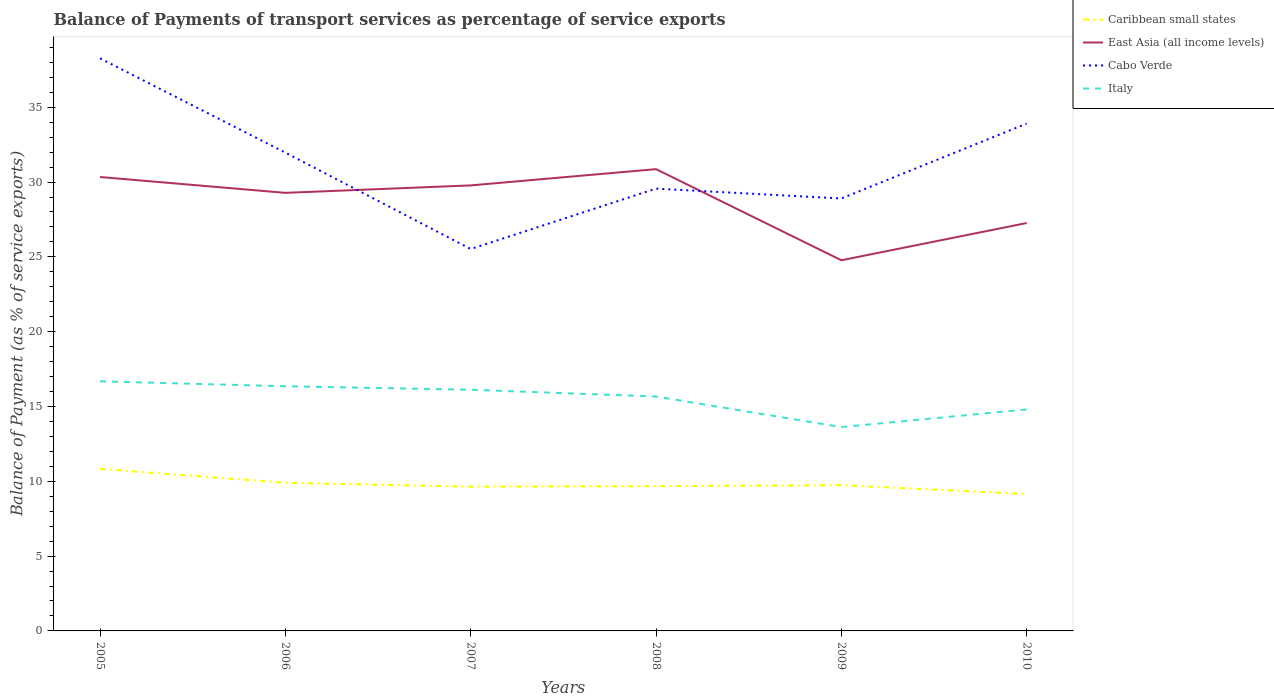Is the number of lines equal to the number of legend labels?
Keep it short and to the point. Yes. Across all years, what is the maximum balance of payments of transport services in Cabo Verde?
Give a very brief answer. 25.53. What is the total balance of payments of transport services in Cabo Verde in the graph?
Ensure brevity in your answer.  8.71. What is the difference between the highest and the second highest balance of payments of transport services in Italy?
Keep it short and to the point. 3.06. How many years are there in the graph?
Your answer should be very brief. 6. What is the difference between two consecutive major ticks on the Y-axis?
Keep it short and to the point. 5. Where does the legend appear in the graph?
Make the answer very short. Top right. How many legend labels are there?
Provide a succinct answer. 4. How are the legend labels stacked?
Provide a succinct answer. Vertical. What is the title of the graph?
Make the answer very short. Balance of Payments of transport services as percentage of service exports. Does "Myanmar" appear as one of the legend labels in the graph?
Provide a short and direct response. No. What is the label or title of the X-axis?
Provide a succinct answer. Years. What is the label or title of the Y-axis?
Offer a very short reply. Balance of Payment (as % of service exports). What is the Balance of Payment (as % of service exports) of Caribbean small states in 2005?
Ensure brevity in your answer.  10.83. What is the Balance of Payment (as % of service exports) of East Asia (all income levels) in 2005?
Your answer should be compact. 30.34. What is the Balance of Payment (as % of service exports) in Cabo Verde in 2005?
Offer a terse response. 38.27. What is the Balance of Payment (as % of service exports) in Italy in 2005?
Offer a very short reply. 16.68. What is the Balance of Payment (as % of service exports) in Caribbean small states in 2006?
Your response must be concise. 9.9. What is the Balance of Payment (as % of service exports) in East Asia (all income levels) in 2006?
Give a very brief answer. 29.28. What is the Balance of Payment (as % of service exports) of Cabo Verde in 2006?
Provide a short and direct response. 31.97. What is the Balance of Payment (as % of service exports) of Italy in 2006?
Give a very brief answer. 16.35. What is the Balance of Payment (as % of service exports) in Caribbean small states in 2007?
Your response must be concise. 9.64. What is the Balance of Payment (as % of service exports) of East Asia (all income levels) in 2007?
Your response must be concise. 29.78. What is the Balance of Payment (as % of service exports) in Cabo Verde in 2007?
Make the answer very short. 25.53. What is the Balance of Payment (as % of service exports) in Italy in 2007?
Your answer should be compact. 16.12. What is the Balance of Payment (as % of service exports) in Caribbean small states in 2008?
Provide a short and direct response. 9.67. What is the Balance of Payment (as % of service exports) of East Asia (all income levels) in 2008?
Your response must be concise. 30.86. What is the Balance of Payment (as % of service exports) in Cabo Verde in 2008?
Provide a short and direct response. 29.56. What is the Balance of Payment (as % of service exports) of Italy in 2008?
Offer a terse response. 15.67. What is the Balance of Payment (as % of service exports) of Caribbean small states in 2009?
Your answer should be very brief. 9.74. What is the Balance of Payment (as % of service exports) in East Asia (all income levels) in 2009?
Offer a very short reply. 24.77. What is the Balance of Payment (as % of service exports) in Cabo Verde in 2009?
Offer a very short reply. 28.9. What is the Balance of Payment (as % of service exports) of Italy in 2009?
Your answer should be very brief. 13.62. What is the Balance of Payment (as % of service exports) in Caribbean small states in 2010?
Your answer should be very brief. 9.15. What is the Balance of Payment (as % of service exports) in East Asia (all income levels) in 2010?
Provide a succinct answer. 27.26. What is the Balance of Payment (as % of service exports) in Cabo Verde in 2010?
Your answer should be very brief. 33.91. What is the Balance of Payment (as % of service exports) in Italy in 2010?
Your answer should be very brief. 14.8. Across all years, what is the maximum Balance of Payment (as % of service exports) in Caribbean small states?
Your response must be concise. 10.83. Across all years, what is the maximum Balance of Payment (as % of service exports) of East Asia (all income levels)?
Give a very brief answer. 30.86. Across all years, what is the maximum Balance of Payment (as % of service exports) of Cabo Verde?
Your answer should be very brief. 38.27. Across all years, what is the maximum Balance of Payment (as % of service exports) in Italy?
Your answer should be very brief. 16.68. Across all years, what is the minimum Balance of Payment (as % of service exports) of Caribbean small states?
Keep it short and to the point. 9.15. Across all years, what is the minimum Balance of Payment (as % of service exports) in East Asia (all income levels)?
Provide a short and direct response. 24.77. Across all years, what is the minimum Balance of Payment (as % of service exports) of Cabo Verde?
Give a very brief answer. 25.53. Across all years, what is the minimum Balance of Payment (as % of service exports) in Italy?
Your response must be concise. 13.62. What is the total Balance of Payment (as % of service exports) in Caribbean small states in the graph?
Give a very brief answer. 58.93. What is the total Balance of Payment (as % of service exports) in East Asia (all income levels) in the graph?
Ensure brevity in your answer.  172.29. What is the total Balance of Payment (as % of service exports) of Cabo Verde in the graph?
Your answer should be very brief. 188.13. What is the total Balance of Payment (as % of service exports) in Italy in the graph?
Offer a terse response. 93.25. What is the difference between the Balance of Payment (as % of service exports) of Caribbean small states in 2005 and that in 2006?
Provide a succinct answer. 0.93. What is the difference between the Balance of Payment (as % of service exports) of East Asia (all income levels) in 2005 and that in 2006?
Your answer should be compact. 1.06. What is the difference between the Balance of Payment (as % of service exports) of Cabo Verde in 2005 and that in 2006?
Ensure brevity in your answer.  6.3. What is the difference between the Balance of Payment (as % of service exports) of Italy in 2005 and that in 2006?
Offer a terse response. 0.33. What is the difference between the Balance of Payment (as % of service exports) in Caribbean small states in 2005 and that in 2007?
Give a very brief answer. 1.19. What is the difference between the Balance of Payment (as % of service exports) in East Asia (all income levels) in 2005 and that in 2007?
Your answer should be very brief. 0.56. What is the difference between the Balance of Payment (as % of service exports) of Cabo Verde in 2005 and that in 2007?
Offer a very short reply. 12.74. What is the difference between the Balance of Payment (as % of service exports) in Italy in 2005 and that in 2007?
Your answer should be very brief. 0.56. What is the difference between the Balance of Payment (as % of service exports) of Caribbean small states in 2005 and that in 2008?
Ensure brevity in your answer.  1.15. What is the difference between the Balance of Payment (as % of service exports) in East Asia (all income levels) in 2005 and that in 2008?
Your answer should be very brief. -0.53. What is the difference between the Balance of Payment (as % of service exports) in Cabo Verde in 2005 and that in 2008?
Offer a very short reply. 8.71. What is the difference between the Balance of Payment (as % of service exports) of Italy in 2005 and that in 2008?
Offer a terse response. 1.02. What is the difference between the Balance of Payment (as % of service exports) in Caribbean small states in 2005 and that in 2009?
Provide a succinct answer. 1.09. What is the difference between the Balance of Payment (as % of service exports) of East Asia (all income levels) in 2005 and that in 2009?
Give a very brief answer. 5.56. What is the difference between the Balance of Payment (as % of service exports) in Cabo Verde in 2005 and that in 2009?
Make the answer very short. 9.36. What is the difference between the Balance of Payment (as % of service exports) in Italy in 2005 and that in 2009?
Your answer should be very brief. 3.06. What is the difference between the Balance of Payment (as % of service exports) in Caribbean small states in 2005 and that in 2010?
Your answer should be compact. 1.68. What is the difference between the Balance of Payment (as % of service exports) in East Asia (all income levels) in 2005 and that in 2010?
Your answer should be compact. 3.08. What is the difference between the Balance of Payment (as % of service exports) of Cabo Verde in 2005 and that in 2010?
Make the answer very short. 4.36. What is the difference between the Balance of Payment (as % of service exports) of Italy in 2005 and that in 2010?
Make the answer very short. 1.88. What is the difference between the Balance of Payment (as % of service exports) in Caribbean small states in 2006 and that in 2007?
Your answer should be compact. 0.26. What is the difference between the Balance of Payment (as % of service exports) in East Asia (all income levels) in 2006 and that in 2007?
Offer a terse response. -0.5. What is the difference between the Balance of Payment (as % of service exports) in Cabo Verde in 2006 and that in 2007?
Offer a terse response. 6.44. What is the difference between the Balance of Payment (as % of service exports) in Italy in 2006 and that in 2007?
Keep it short and to the point. 0.23. What is the difference between the Balance of Payment (as % of service exports) in Caribbean small states in 2006 and that in 2008?
Provide a short and direct response. 0.23. What is the difference between the Balance of Payment (as % of service exports) in East Asia (all income levels) in 2006 and that in 2008?
Give a very brief answer. -1.58. What is the difference between the Balance of Payment (as % of service exports) of Cabo Verde in 2006 and that in 2008?
Provide a succinct answer. 2.41. What is the difference between the Balance of Payment (as % of service exports) in Italy in 2006 and that in 2008?
Offer a very short reply. 0.69. What is the difference between the Balance of Payment (as % of service exports) in Caribbean small states in 2006 and that in 2009?
Your response must be concise. 0.16. What is the difference between the Balance of Payment (as % of service exports) in East Asia (all income levels) in 2006 and that in 2009?
Provide a succinct answer. 4.51. What is the difference between the Balance of Payment (as % of service exports) of Cabo Verde in 2006 and that in 2009?
Your answer should be compact. 3.06. What is the difference between the Balance of Payment (as % of service exports) in Italy in 2006 and that in 2009?
Give a very brief answer. 2.73. What is the difference between the Balance of Payment (as % of service exports) in Caribbean small states in 2006 and that in 2010?
Your answer should be very brief. 0.75. What is the difference between the Balance of Payment (as % of service exports) of East Asia (all income levels) in 2006 and that in 2010?
Provide a succinct answer. 2.02. What is the difference between the Balance of Payment (as % of service exports) in Cabo Verde in 2006 and that in 2010?
Offer a very short reply. -1.94. What is the difference between the Balance of Payment (as % of service exports) in Italy in 2006 and that in 2010?
Give a very brief answer. 1.55. What is the difference between the Balance of Payment (as % of service exports) in Caribbean small states in 2007 and that in 2008?
Offer a terse response. -0.04. What is the difference between the Balance of Payment (as % of service exports) of East Asia (all income levels) in 2007 and that in 2008?
Your response must be concise. -1.09. What is the difference between the Balance of Payment (as % of service exports) in Cabo Verde in 2007 and that in 2008?
Provide a succinct answer. -4.03. What is the difference between the Balance of Payment (as % of service exports) in Italy in 2007 and that in 2008?
Your answer should be compact. 0.45. What is the difference between the Balance of Payment (as % of service exports) of Caribbean small states in 2007 and that in 2009?
Offer a very short reply. -0.1. What is the difference between the Balance of Payment (as % of service exports) of East Asia (all income levels) in 2007 and that in 2009?
Provide a succinct answer. 5. What is the difference between the Balance of Payment (as % of service exports) in Cabo Verde in 2007 and that in 2009?
Provide a short and direct response. -3.38. What is the difference between the Balance of Payment (as % of service exports) of Italy in 2007 and that in 2009?
Your answer should be compact. 2.49. What is the difference between the Balance of Payment (as % of service exports) in Caribbean small states in 2007 and that in 2010?
Keep it short and to the point. 0.49. What is the difference between the Balance of Payment (as % of service exports) in East Asia (all income levels) in 2007 and that in 2010?
Give a very brief answer. 2.51. What is the difference between the Balance of Payment (as % of service exports) of Cabo Verde in 2007 and that in 2010?
Provide a succinct answer. -8.38. What is the difference between the Balance of Payment (as % of service exports) of Italy in 2007 and that in 2010?
Your response must be concise. 1.32. What is the difference between the Balance of Payment (as % of service exports) in Caribbean small states in 2008 and that in 2009?
Offer a very short reply. -0.07. What is the difference between the Balance of Payment (as % of service exports) in East Asia (all income levels) in 2008 and that in 2009?
Your answer should be compact. 6.09. What is the difference between the Balance of Payment (as % of service exports) of Cabo Verde in 2008 and that in 2009?
Offer a very short reply. 0.66. What is the difference between the Balance of Payment (as % of service exports) of Italy in 2008 and that in 2009?
Provide a short and direct response. 2.04. What is the difference between the Balance of Payment (as % of service exports) of Caribbean small states in 2008 and that in 2010?
Offer a terse response. 0.52. What is the difference between the Balance of Payment (as % of service exports) of East Asia (all income levels) in 2008 and that in 2010?
Ensure brevity in your answer.  3.6. What is the difference between the Balance of Payment (as % of service exports) in Cabo Verde in 2008 and that in 2010?
Your answer should be compact. -4.35. What is the difference between the Balance of Payment (as % of service exports) of Italy in 2008 and that in 2010?
Your answer should be very brief. 0.86. What is the difference between the Balance of Payment (as % of service exports) of Caribbean small states in 2009 and that in 2010?
Offer a terse response. 0.59. What is the difference between the Balance of Payment (as % of service exports) of East Asia (all income levels) in 2009 and that in 2010?
Make the answer very short. -2.49. What is the difference between the Balance of Payment (as % of service exports) in Cabo Verde in 2009 and that in 2010?
Your answer should be compact. -5.01. What is the difference between the Balance of Payment (as % of service exports) in Italy in 2009 and that in 2010?
Provide a short and direct response. -1.18. What is the difference between the Balance of Payment (as % of service exports) in Caribbean small states in 2005 and the Balance of Payment (as % of service exports) in East Asia (all income levels) in 2006?
Offer a very short reply. -18.45. What is the difference between the Balance of Payment (as % of service exports) in Caribbean small states in 2005 and the Balance of Payment (as % of service exports) in Cabo Verde in 2006?
Your answer should be very brief. -21.14. What is the difference between the Balance of Payment (as % of service exports) in Caribbean small states in 2005 and the Balance of Payment (as % of service exports) in Italy in 2006?
Ensure brevity in your answer.  -5.52. What is the difference between the Balance of Payment (as % of service exports) of East Asia (all income levels) in 2005 and the Balance of Payment (as % of service exports) of Cabo Verde in 2006?
Ensure brevity in your answer.  -1.63. What is the difference between the Balance of Payment (as % of service exports) in East Asia (all income levels) in 2005 and the Balance of Payment (as % of service exports) in Italy in 2006?
Give a very brief answer. 13.98. What is the difference between the Balance of Payment (as % of service exports) in Cabo Verde in 2005 and the Balance of Payment (as % of service exports) in Italy in 2006?
Your answer should be compact. 21.92. What is the difference between the Balance of Payment (as % of service exports) of Caribbean small states in 2005 and the Balance of Payment (as % of service exports) of East Asia (all income levels) in 2007?
Your response must be concise. -18.95. What is the difference between the Balance of Payment (as % of service exports) in Caribbean small states in 2005 and the Balance of Payment (as % of service exports) in Cabo Verde in 2007?
Offer a very short reply. -14.7. What is the difference between the Balance of Payment (as % of service exports) in Caribbean small states in 2005 and the Balance of Payment (as % of service exports) in Italy in 2007?
Your response must be concise. -5.29. What is the difference between the Balance of Payment (as % of service exports) of East Asia (all income levels) in 2005 and the Balance of Payment (as % of service exports) of Cabo Verde in 2007?
Offer a terse response. 4.81. What is the difference between the Balance of Payment (as % of service exports) of East Asia (all income levels) in 2005 and the Balance of Payment (as % of service exports) of Italy in 2007?
Provide a succinct answer. 14.22. What is the difference between the Balance of Payment (as % of service exports) in Cabo Verde in 2005 and the Balance of Payment (as % of service exports) in Italy in 2007?
Offer a terse response. 22.15. What is the difference between the Balance of Payment (as % of service exports) in Caribbean small states in 2005 and the Balance of Payment (as % of service exports) in East Asia (all income levels) in 2008?
Make the answer very short. -20.03. What is the difference between the Balance of Payment (as % of service exports) in Caribbean small states in 2005 and the Balance of Payment (as % of service exports) in Cabo Verde in 2008?
Make the answer very short. -18.73. What is the difference between the Balance of Payment (as % of service exports) in Caribbean small states in 2005 and the Balance of Payment (as % of service exports) in Italy in 2008?
Keep it short and to the point. -4.84. What is the difference between the Balance of Payment (as % of service exports) of East Asia (all income levels) in 2005 and the Balance of Payment (as % of service exports) of Cabo Verde in 2008?
Offer a terse response. 0.78. What is the difference between the Balance of Payment (as % of service exports) in East Asia (all income levels) in 2005 and the Balance of Payment (as % of service exports) in Italy in 2008?
Your answer should be compact. 14.67. What is the difference between the Balance of Payment (as % of service exports) in Cabo Verde in 2005 and the Balance of Payment (as % of service exports) in Italy in 2008?
Make the answer very short. 22.6. What is the difference between the Balance of Payment (as % of service exports) of Caribbean small states in 2005 and the Balance of Payment (as % of service exports) of East Asia (all income levels) in 2009?
Offer a very short reply. -13.94. What is the difference between the Balance of Payment (as % of service exports) of Caribbean small states in 2005 and the Balance of Payment (as % of service exports) of Cabo Verde in 2009?
Keep it short and to the point. -18.07. What is the difference between the Balance of Payment (as % of service exports) in Caribbean small states in 2005 and the Balance of Payment (as % of service exports) in Italy in 2009?
Provide a succinct answer. -2.8. What is the difference between the Balance of Payment (as % of service exports) of East Asia (all income levels) in 2005 and the Balance of Payment (as % of service exports) of Cabo Verde in 2009?
Your answer should be very brief. 1.43. What is the difference between the Balance of Payment (as % of service exports) in East Asia (all income levels) in 2005 and the Balance of Payment (as % of service exports) in Italy in 2009?
Offer a terse response. 16.71. What is the difference between the Balance of Payment (as % of service exports) in Cabo Verde in 2005 and the Balance of Payment (as % of service exports) in Italy in 2009?
Your answer should be compact. 24.64. What is the difference between the Balance of Payment (as % of service exports) in Caribbean small states in 2005 and the Balance of Payment (as % of service exports) in East Asia (all income levels) in 2010?
Provide a short and direct response. -16.43. What is the difference between the Balance of Payment (as % of service exports) of Caribbean small states in 2005 and the Balance of Payment (as % of service exports) of Cabo Verde in 2010?
Your response must be concise. -23.08. What is the difference between the Balance of Payment (as % of service exports) in Caribbean small states in 2005 and the Balance of Payment (as % of service exports) in Italy in 2010?
Your answer should be very brief. -3.97. What is the difference between the Balance of Payment (as % of service exports) in East Asia (all income levels) in 2005 and the Balance of Payment (as % of service exports) in Cabo Verde in 2010?
Your response must be concise. -3.57. What is the difference between the Balance of Payment (as % of service exports) in East Asia (all income levels) in 2005 and the Balance of Payment (as % of service exports) in Italy in 2010?
Ensure brevity in your answer.  15.53. What is the difference between the Balance of Payment (as % of service exports) of Cabo Verde in 2005 and the Balance of Payment (as % of service exports) of Italy in 2010?
Provide a short and direct response. 23.46. What is the difference between the Balance of Payment (as % of service exports) of Caribbean small states in 2006 and the Balance of Payment (as % of service exports) of East Asia (all income levels) in 2007?
Provide a succinct answer. -19.88. What is the difference between the Balance of Payment (as % of service exports) of Caribbean small states in 2006 and the Balance of Payment (as % of service exports) of Cabo Verde in 2007?
Your response must be concise. -15.63. What is the difference between the Balance of Payment (as % of service exports) in Caribbean small states in 2006 and the Balance of Payment (as % of service exports) in Italy in 2007?
Keep it short and to the point. -6.22. What is the difference between the Balance of Payment (as % of service exports) in East Asia (all income levels) in 2006 and the Balance of Payment (as % of service exports) in Cabo Verde in 2007?
Give a very brief answer. 3.75. What is the difference between the Balance of Payment (as % of service exports) in East Asia (all income levels) in 2006 and the Balance of Payment (as % of service exports) in Italy in 2007?
Offer a very short reply. 13.16. What is the difference between the Balance of Payment (as % of service exports) of Cabo Verde in 2006 and the Balance of Payment (as % of service exports) of Italy in 2007?
Provide a succinct answer. 15.85. What is the difference between the Balance of Payment (as % of service exports) of Caribbean small states in 2006 and the Balance of Payment (as % of service exports) of East Asia (all income levels) in 2008?
Your answer should be very brief. -20.96. What is the difference between the Balance of Payment (as % of service exports) of Caribbean small states in 2006 and the Balance of Payment (as % of service exports) of Cabo Verde in 2008?
Provide a short and direct response. -19.66. What is the difference between the Balance of Payment (as % of service exports) in Caribbean small states in 2006 and the Balance of Payment (as % of service exports) in Italy in 2008?
Give a very brief answer. -5.77. What is the difference between the Balance of Payment (as % of service exports) of East Asia (all income levels) in 2006 and the Balance of Payment (as % of service exports) of Cabo Verde in 2008?
Offer a terse response. -0.28. What is the difference between the Balance of Payment (as % of service exports) in East Asia (all income levels) in 2006 and the Balance of Payment (as % of service exports) in Italy in 2008?
Your answer should be compact. 13.61. What is the difference between the Balance of Payment (as % of service exports) in Cabo Verde in 2006 and the Balance of Payment (as % of service exports) in Italy in 2008?
Offer a terse response. 16.3. What is the difference between the Balance of Payment (as % of service exports) of Caribbean small states in 2006 and the Balance of Payment (as % of service exports) of East Asia (all income levels) in 2009?
Your answer should be very brief. -14.87. What is the difference between the Balance of Payment (as % of service exports) of Caribbean small states in 2006 and the Balance of Payment (as % of service exports) of Cabo Verde in 2009?
Ensure brevity in your answer.  -19. What is the difference between the Balance of Payment (as % of service exports) in Caribbean small states in 2006 and the Balance of Payment (as % of service exports) in Italy in 2009?
Your answer should be compact. -3.72. What is the difference between the Balance of Payment (as % of service exports) in East Asia (all income levels) in 2006 and the Balance of Payment (as % of service exports) in Cabo Verde in 2009?
Offer a very short reply. 0.38. What is the difference between the Balance of Payment (as % of service exports) in East Asia (all income levels) in 2006 and the Balance of Payment (as % of service exports) in Italy in 2009?
Offer a very short reply. 15.65. What is the difference between the Balance of Payment (as % of service exports) of Cabo Verde in 2006 and the Balance of Payment (as % of service exports) of Italy in 2009?
Keep it short and to the point. 18.34. What is the difference between the Balance of Payment (as % of service exports) of Caribbean small states in 2006 and the Balance of Payment (as % of service exports) of East Asia (all income levels) in 2010?
Make the answer very short. -17.36. What is the difference between the Balance of Payment (as % of service exports) of Caribbean small states in 2006 and the Balance of Payment (as % of service exports) of Cabo Verde in 2010?
Offer a very short reply. -24.01. What is the difference between the Balance of Payment (as % of service exports) in Caribbean small states in 2006 and the Balance of Payment (as % of service exports) in Italy in 2010?
Offer a very short reply. -4.9. What is the difference between the Balance of Payment (as % of service exports) in East Asia (all income levels) in 2006 and the Balance of Payment (as % of service exports) in Cabo Verde in 2010?
Offer a terse response. -4.63. What is the difference between the Balance of Payment (as % of service exports) in East Asia (all income levels) in 2006 and the Balance of Payment (as % of service exports) in Italy in 2010?
Offer a very short reply. 14.48. What is the difference between the Balance of Payment (as % of service exports) of Cabo Verde in 2006 and the Balance of Payment (as % of service exports) of Italy in 2010?
Offer a terse response. 17.16. What is the difference between the Balance of Payment (as % of service exports) in Caribbean small states in 2007 and the Balance of Payment (as % of service exports) in East Asia (all income levels) in 2008?
Offer a terse response. -21.22. What is the difference between the Balance of Payment (as % of service exports) in Caribbean small states in 2007 and the Balance of Payment (as % of service exports) in Cabo Verde in 2008?
Offer a very short reply. -19.92. What is the difference between the Balance of Payment (as % of service exports) in Caribbean small states in 2007 and the Balance of Payment (as % of service exports) in Italy in 2008?
Your answer should be compact. -6.03. What is the difference between the Balance of Payment (as % of service exports) in East Asia (all income levels) in 2007 and the Balance of Payment (as % of service exports) in Cabo Verde in 2008?
Offer a terse response. 0.22. What is the difference between the Balance of Payment (as % of service exports) of East Asia (all income levels) in 2007 and the Balance of Payment (as % of service exports) of Italy in 2008?
Offer a terse response. 14.11. What is the difference between the Balance of Payment (as % of service exports) of Cabo Verde in 2007 and the Balance of Payment (as % of service exports) of Italy in 2008?
Your answer should be very brief. 9.86. What is the difference between the Balance of Payment (as % of service exports) in Caribbean small states in 2007 and the Balance of Payment (as % of service exports) in East Asia (all income levels) in 2009?
Give a very brief answer. -15.13. What is the difference between the Balance of Payment (as % of service exports) in Caribbean small states in 2007 and the Balance of Payment (as % of service exports) in Cabo Verde in 2009?
Make the answer very short. -19.26. What is the difference between the Balance of Payment (as % of service exports) in Caribbean small states in 2007 and the Balance of Payment (as % of service exports) in Italy in 2009?
Keep it short and to the point. -3.98. What is the difference between the Balance of Payment (as % of service exports) of East Asia (all income levels) in 2007 and the Balance of Payment (as % of service exports) of Cabo Verde in 2009?
Your answer should be compact. 0.87. What is the difference between the Balance of Payment (as % of service exports) of East Asia (all income levels) in 2007 and the Balance of Payment (as % of service exports) of Italy in 2009?
Keep it short and to the point. 16.15. What is the difference between the Balance of Payment (as % of service exports) of Cabo Verde in 2007 and the Balance of Payment (as % of service exports) of Italy in 2009?
Offer a very short reply. 11.9. What is the difference between the Balance of Payment (as % of service exports) in Caribbean small states in 2007 and the Balance of Payment (as % of service exports) in East Asia (all income levels) in 2010?
Ensure brevity in your answer.  -17.62. What is the difference between the Balance of Payment (as % of service exports) of Caribbean small states in 2007 and the Balance of Payment (as % of service exports) of Cabo Verde in 2010?
Provide a succinct answer. -24.27. What is the difference between the Balance of Payment (as % of service exports) in Caribbean small states in 2007 and the Balance of Payment (as % of service exports) in Italy in 2010?
Ensure brevity in your answer.  -5.16. What is the difference between the Balance of Payment (as % of service exports) of East Asia (all income levels) in 2007 and the Balance of Payment (as % of service exports) of Cabo Verde in 2010?
Keep it short and to the point. -4.13. What is the difference between the Balance of Payment (as % of service exports) of East Asia (all income levels) in 2007 and the Balance of Payment (as % of service exports) of Italy in 2010?
Your answer should be very brief. 14.97. What is the difference between the Balance of Payment (as % of service exports) of Cabo Verde in 2007 and the Balance of Payment (as % of service exports) of Italy in 2010?
Provide a succinct answer. 10.72. What is the difference between the Balance of Payment (as % of service exports) of Caribbean small states in 2008 and the Balance of Payment (as % of service exports) of East Asia (all income levels) in 2009?
Make the answer very short. -15.1. What is the difference between the Balance of Payment (as % of service exports) of Caribbean small states in 2008 and the Balance of Payment (as % of service exports) of Cabo Verde in 2009?
Make the answer very short. -19.23. What is the difference between the Balance of Payment (as % of service exports) in Caribbean small states in 2008 and the Balance of Payment (as % of service exports) in Italy in 2009?
Ensure brevity in your answer.  -3.95. What is the difference between the Balance of Payment (as % of service exports) in East Asia (all income levels) in 2008 and the Balance of Payment (as % of service exports) in Cabo Verde in 2009?
Offer a terse response. 1.96. What is the difference between the Balance of Payment (as % of service exports) in East Asia (all income levels) in 2008 and the Balance of Payment (as % of service exports) in Italy in 2009?
Your response must be concise. 17.24. What is the difference between the Balance of Payment (as % of service exports) of Cabo Verde in 2008 and the Balance of Payment (as % of service exports) of Italy in 2009?
Your answer should be compact. 15.94. What is the difference between the Balance of Payment (as % of service exports) in Caribbean small states in 2008 and the Balance of Payment (as % of service exports) in East Asia (all income levels) in 2010?
Offer a very short reply. -17.59. What is the difference between the Balance of Payment (as % of service exports) in Caribbean small states in 2008 and the Balance of Payment (as % of service exports) in Cabo Verde in 2010?
Make the answer very short. -24.23. What is the difference between the Balance of Payment (as % of service exports) of Caribbean small states in 2008 and the Balance of Payment (as % of service exports) of Italy in 2010?
Offer a terse response. -5.13. What is the difference between the Balance of Payment (as % of service exports) of East Asia (all income levels) in 2008 and the Balance of Payment (as % of service exports) of Cabo Verde in 2010?
Give a very brief answer. -3.05. What is the difference between the Balance of Payment (as % of service exports) in East Asia (all income levels) in 2008 and the Balance of Payment (as % of service exports) in Italy in 2010?
Your response must be concise. 16.06. What is the difference between the Balance of Payment (as % of service exports) in Cabo Verde in 2008 and the Balance of Payment (as % of service exports) in Italy in 2010?
Offer a terse response. 14.76. What is the difference between the Balance of Payment (as % of service exports) in Caribbean small states in 2009 and the Balance of Payment (as % of service exports) in East Asia (all income levels) in 2010?
Give a very brief answer. -17.52. What is the difference between the Balance of Payment (as % of service exports) in Caribbean small states in 2009 and the Balance of Payment (as % of service exports) in Cabo Verde in 2010?
Your answer should be very brief. -24.17. What is the difference between the Balance of Payment (as % of service exports) of Caribbean small states in 2009 and the Balance of Payment (as % of service exports) of Italy in 2010?
Your answer should be very brief. -5.06. What is the difference between the Balance of Payment (as % of service exports) in East Asia (all income levels) in 2009 and the Balance of Payment (as % of service exports) in Cabo Verde in 2010?
Give a very brief answer. -9.13. What is the difference between the Balance of Payment (as % of service exports) in East Asia (all income levels) in 2009 and the Balance of Payment (as % of service exports) in Italy in 2010?
Provide a short and direct response. 9.97. What is the difference between the Balance of Payment (as % of service exports) of Cabo Verde in 2009 and the Balance of Payment (as % of service exports) of Italy in 2010?
Your answer should be very brief. 14.1. What is the average Balance of Payment (as % of service exports) in Caribbean small states per year?
Your response must be concise. 9.82. What is the average Balance of Payment (as % of service exports) of East Asia (all income levels) per year?
Make the answer very short. 28.71. What is the average Balance of Payment (as % of service exports) of Cabo Verde per year?
Offer a very short reply. 31.35. What is the average Balance of Payment (as % of service exports) in Italy per year?
Provide a succinct answer. 15.54. In the year 2005, what is the difference between the Balance of Payment (as % of service exports) of Caribbean small states and Balance of Payment (as % of service exports) of East Asia (all income levels)?
Your response must be concise. -19.51. In the year 2005, what is the difference between the Balance of Payment (as % of service exports) in Caribbean small states and Balance of Payment (as % of service exports) in Cabo Verde?
Provide a succinct answer. -27.44. In the year 2005, what is the difference between the Balance of Payment (as % of service exports) in Caribbean small states and Balance of Payment (as % of service exports) in Italy?
Make the answer very short. -5.85. In the year 2005, what is the difference between the Balance of Payment (as % of service exports) of East Asia (all income levels) and Balance of Payment (as % of service exports) of Cabo Verde?
Provide a succinct answer. -7.93. In the year 2005, what is the difference between the Balance of Payment (as % of service exports) of East Asia (all income levels) and Balance of Payment (as % of service exports) of Italy?
Your answer should be very brief. 13.65. In the year 2005, what is the difference between the Balance of Payment (as % of service exports) in Cabo Verde and Balance of Payment (as % of service exports) in Italy?
Give a very brief answer. 21.58. In the year 2006, what is the difference between the Balance of Payment (as % of service exports) of Caribbean small states and Balance of Payment (as % of service exports) of East Asia (all income levels)?
Ensure brevity in your answer.  -19.38. In the year 2006, what is the difference between the Balance of Payment (as % of service exports) in Caribbean small states and Balance of Payment (as % of service exports) in Cabo Verde?
Make the answer very short. -22.07. In the year 2006, what is the difference between the Balance of Payment (as % of service exports) in Caribbean small states and Balance of Payment (as % of service exports) in Italy?
Offer a terse response. -6.45. In the year 2006, what is the difference between the Balance of Payment (as % of service exports) in East Asia (all income levels) and Balance of Payment (as % of service exports) in Cabo Verde?
Make the answer very short. -2.69. In the year 2006, what is the difference between the Balance of Payment (as % of service exports) of East Asia (all income levels) and Balance of Payment (as % of service exports) of Italy?
Provide a succinct answer. 12.93. In the year 2006, what is the difference between the Balance of Payment (as % of service exports) in Cabo Verde and Balance of Payment (as % of service exports) in Italy?
Provide a succinct answer. 15.61. In the year 2007, what is the difference between the Balance of Payment (as % of service exports) of Caribbean small states and Balance of Payment (as % of service exports) of East Asia (all income levels)?
Make the answer very short. -20.14. In the year 2007, what is the difference between the Balance of Payment (as % of service exports) in Caribbean small states and Balance of Payment (as % of service exports) in Cabo Verde?
Your answer should be compact. -15.89. In the year 2007, what is the difference between the Balance of Payment (as % of service exports) of Caribbean small states and Balance of Payment (as % of service exports) of Italy?
Your answer should be compact. -6.48. In the year 2007, what is the difference between the Balance of Payment (as % of service exports) in East Asia (all income levels) and Balance of Payment (as % of service exports) in Cabo Verde?
Keep it short and to the point. 4.25. In the year 2007, what is the difference between the Balance of Payment (as % of service exports) in East Asia (all income levels) and Balance of Payment (as % of service exports) in Italy?
Keep it short and to the point. 13.66. In the year 2007, what is the difference between the Balance of Payment (as % of service exports) in Cabo Verde and Balance of Payment (as % of service exports) in Italy?
Your response must be concise. 9.41. In the year 2008, what is the difference between the Balance of Payment (as % of service exports) of Caribbean small states and Balance of Payment (as % of service exports) of East Asia (all income levels)?
Make the answer very short. -21.19. In the year 2008, what is the difference between the Balance of Payment (as % of service exports) in Caribbean small states and Balance of Payment (as % of service exports) in Cabo Verde?
Keep it short and to the point. -19.89. In the year 2008, what is the difference between the Balance of Payment (as % of service exports) in Caribbean small states and Balance of Payment (as % of service exports) in Italy?
Keep it short and to the point. -5.99. In the year 2008, what is the difference between the Balance of Payment (as % of service exports) in East Asia (all income levels) and Balance of Payment (as % of service exports) in Cabo Verde?
Your response must be concise. 1.3. In the year 2008, what is the difference between the Balance of Payment (as % of service exports) in East Asia (all income levels) and Balance of Payment (as % of service exports) in Italy?
Provide a succinct answer. 15.2. In the year 2008, what is the difference between the Balance of Payment (as % of service exports) in Cabo Verde and Balance of Payment (as % of service exports) in Italy?
Offer a terse response. 13.89. In the year 2009, what is the difference between the Balance of Payment (as % of service exports) of Caribbean small states and Balance of Payment (as % of service exports) of East Asia (all income levels)?
Your response must be concise. -15.03. In the year 2009, what is the difference between the Balance of Payment (as % of service exports) in Caribbean small states and Balance of Payment (as % of service exports) in Cabo Verde?
Provide a short and direct response. -19.16. In the year 2009, what is the difference between the Balance of Payment (as % of service exports) of Caribbean small states and Balance of Payment (as % of service exports) of Italy?
Your answer should be compact. -3.88. In the year 2009, what is the difference between the Balance of Payment (as % of service exports) of East Asia (all income levels) and Balance of Payment (as % of service exports) of Cabo Verde?
Your response must be concise. -4.13. In the year 2009, what is the difference between the Balance of Payment (as % of service exports) of East Asia (all income levels) and Balance of Payment (as % of service exports) of Italy?
Ensure brevity in your answer.  11.15. In the year 2009, what is the difference between the Balance of Payment (as % of service exports) of Cabo Verde and Balance of Payment (as % of service exports) of Italy?
Give a very brief answer. 15.28. In the year 2010, what is the difference between the Balance of Payment (as % of service exports) of Caribbean small states and Balance of Payment (as % of service exports) of East Asia (all income levels)?
Your answer should be compact. -18.11. In the year 2010, what is the difference between the Balance of Payment (as % of service exports) in Caribbean small states and Balance of Payment (as % of service exports) in Cabo Verde?
Your answer should be compact. -24.76. In the year 2010, what is the difference between the Balance of Payment (as % of service exports) of Caribbean small states and Balance of Payment (as % of service exports) of Italy?
Your answer should be compact. -5.65. In the year 2010, what is the difference between the Balance of Payment (as % of service exports) in East Asia (all income levels) and Balance of Payment (as % of service exports) in Cabo Verde?
Ensure brevity in your answer.  -6.65. In the year 2010, what is the difference between the Balance of Payment (as % of service exports) of East Asia (all income levels) and Balance of Payment (as % of service exports) of Italy?
Your answer should be very brief. 12.46. In the year 2010, what is the difference between the Balance of Payment (as % of service exports) in Cabo Verde and Balance of Payment (as % of service exports) in Italy?
Give a very brief answer. 19.11. What is the ratio of the Balance of Payment (as % of service exports) in Caribbean small states in 2005 to that in 2006?
Your response must be concise. 1.09. What is the ratio of the Balance of Payment (as % of service exports) of East Asia (all income levels) in 2005 to that in 2006?
Ensure brevity in your answer.  1.04. What is the ratio of the Balance of Payment (as % of service exports) of Cabo Verde in 2005 to that in 2006?
Offer a very short reply. 1.2. What is the ratio of the Balance of Payment (as % of service exports) of Italy in 2005 to that in 2006?
Your response must be concise. 1.02. What is the ratio of the Balance of Payment (as % of service exports) in Caribbean small states in 2005 to that in 2007?
Offer a very short reply. 1.12. What is the ratio of the Balance of Payment (as % of service exports) of East Asia (all income levels) in 2005 to that in 2007?
Offer a very short reply. 1.02. What is the ratio of the Balance of Payment (as % of service exports) in Cabo Verde in 2005 to that in 2007?
Your response must be concise. 1.5. What is the ratio of the Balance of Payment (as % of service exports) in Italy in 2005 to that in 2007?
Provide a succinct answer. 1.03. What is the ratio of the Balance of Payment (as % of service exports) in Caribbean small states in 2005 to that in 2008?
Keep it short and to the point. 1.12. What is the ratio of the Balance of Payment (as % of service exports) of Cabo Verde in 2005 to that in 2008?
Make the answer very short. 1.29. What is the ratio of the Balance of Payment (as % of service exports) in Italy in 2005 to that in 2008?
Offer a terse response. 1.06. What is the ratio of the Balance of Payment (as % of service exports) of Caribbean small states in 2005 to that in 2009?
Make the answer very short. 1.11. What is the ratio of the Balance of Payment (as % of service exports) of East Asia (all income levels) in 2005 to that in 2009?
Provide a short and direct response. 1.22. What is the ratio of the Balance of Payment (as % of service exports) of Cabo Verde in 2005 to that in 2009?
Provide a succinct answer. 1.32. What is the ratio of the Balance of Payment (as % of service exports) of Italy in 2005 to that in 2009?
Your response must be concise. 1.22. What is the ratio of the Balance of Payment (as % of service exports) in Caribbean small states in 2005 to that in 2010?
Offer a terse response. 1.18. What is the ratio of the Balance of Payment (as % of service exports) of East Asia (all income levels) in 2005 to that in 2010?
Provide a short and direct response. 1.11. What is the ratio of the Balance of Payment (as % of service exports) in Cabo Verde in 2005 to that in 2010?
Your answer should be very brief. 1.13. What is the ratio of the Balance of Payment (as % of service exports) in Italy in 2005 to that in 2010?
Provide a succinct answer. 1.13. What is the ratio of the Balance of Payment (as % of service exports) in East Asia (all income levels) in 2006 to that in 2007?
Give a very brief answer. 0.98. What is the ratio of the Balance of Payment (as % of service exports) in Cabo Verde in 2006 to that in 2007?
Ensure brevity in your answer.  1.25. What is the ratio of the Balance of Payment (as % of service exports) of Italy in 2006 to that in 2007?
Give a very brief answer. 1.01. What is the ratio of the Balance of Payment (as % of service exports) in Caribbean small states in 2006 to that in 2008?
Make the answer very short. 1.02. What is the ratio of the Balance of Payment (as % of service exports) in East Asia (all income levels) in 2006 to that in 2008?
Keep it short and to the point. 0.95. What is the ratio of the Balance of Payment (as % of service exports) of Cabo Verde in 2006 to that in 2008?
Your answer should be very brief. 1.08. What is the ratio of the Balance of Payment (as % of service exports) in Italy in 2006 to that in 2008?
Make the answer very short. 1.04. What is the ratio of the Balance of Payment (as % of service exports) in Caribbean small states in 2006 to that in 2009?
Keep it short and to the point. 1.02. What is the ratio of the Balance of Payment (as % of service exports) of East Asia (all income levels) in 2006 to that in 2009?
Give a very brief answer. 1.18. What is the ratio of the Balance of Payment (as % of service exports) of Cabo Verde in 2006 to that in 2009?
Keep it short and to the point. 1.11. What is the ratio of the Balance of Payment (as % of service exports) in Italy in 2006 to that in 2009?
Your answer should be compact. 1.2. What is the ratio of the Balance of Payment (as % of service exports) of Caribbean small states in 2006 to that in 2010?
Ensure brevity in your answer.  1.08. What is the ratio of the Balance of Payment (as % of service exports) of East Asia (all income levels) in 2006 to that in 2010?
Ensure brevity in your answer.  1.07. What is the ratio of the Balance of Payment (as % of service exports) in Cabo Verde in 2006 to that in 2010?
Ensure brevity in your answer.  0.94. What is the ratio of the Balance of Payment (as % of service exports) in Italy in 2006 to that in 2010?
Offer a terse response. 1.1. What is the ratio of the Balance of Payment (as % of service exports) in East Asia (all income levels) in 2007 to that in 2008?
Provide a short and direct response. 0.96. What is the ratio of the Balance of Payment (as % of service exports) in Cabo Verde in 2007 to that in 2008?
Your answer should be very brief. 0.86. What is the ratio of the Balance of Payment (as % of service exports) of Italy in 2007 to that in 2008?
Offer a terse response. 1.03. What is the ratio of the Balance of Payment (as % of service exports) in East Asia (all income levels) in 2007 to that in 2009?
Give a very brief answer. 1.2. What is the ratio of the Balance of Payment (as % of service exports) of Cabo Verde in 2007 to that in 2009?
Keep it short and to the point. 0.88. What is the ratio of the Balance of Payment (as % of service exports) in Italy in 2007 to that in 2009?
Offer a very short reply. 1.18. What is the ratio of the Balance of Payment (as % of service exports) of Caribbean small states in 2007 to that in 2010?
Ensure brevity in your answer.  1.05. What is the ratio of the Balance of Payment (as % of service exports) in East Asia (all income levels) in 2007 to that in 2010?
Keep it short and to the point. 1.09. What is the ratio of the Balance of Payment (as % of service exports) of Cabo Verde in 2007 to that in 2010?
Make the answer very short. 0.75. What is the ratio of the Balance of Payment (as % of service exports) of Italy in 2007 to that in 2010?
Give a very brief answer. 1.09. What is the ratio of the Balance of Payment (as % of service exports) of Caribbean small states in 2008 to that in 2009?
Make the answer very short. 0.99. What is the ratio of the Balance of Payment (as % of service exports) of East Asia (all income levels) in 2008 to that in 2009?
Make the answer very short. 1.25. What is the ratio of the Balance of Payment (as % of service exports) in Cabo Verde in 2008 to that in 2009?
Your response must be concise. 1.02. What is the ratio of the Balance of Payment (as % of service exports) of Italy in 2008 to that in 2009?
Provide a succinct answer. 1.15. What is the ratio of the Balance of Payment (as % of service exports) in Caribbean small states in 2008 to that in 2010?
Offer a very short reply. 1.06. What is the ratio of the Balance of Payment (as % of service exports) of East Asia (all income levels) in 2008 to that in 2010?
Your answer should be very brief. 1.13. What is the ratio of the Balance of Payment (as % of service exports) in Cabo Verde in 2008 to that in 2010?
Provide a short and direct response. 0.87. What is the ratio of the Balance of Payment (as % of service exports) of Italy in 2008 to that in 2010?
Keep it short and to the point. 1.06. What is the ratio of the Balance of Payment (as % of service exports) of Caribbean small states in 2009 to that in 2010?
Your answer should be very brief. 1.06. What is the ratio of the Balance of Payment (as % of service exports) of East Asia (all income levels) in 2009 to that in 2010?
Ensure brevity in your answer.  0.91. What is the ratio of the Balance of Payment (as % of service exports) in Cabo Verde in 2009 to that in 2010?
Make the answer very short. 0.85. What is the ratio of the Balance of Payment (as % of service exports) of Italy in 2009 to that in 2010?
Ensure brevity in your answer.  0.92. What is the difference between the highest and the second highest Balance of Payment (as % of service exports) of Caribbean small states?
Your answer should be very brief. 0.93. What is the difference between the highest and the second highest Balance of Payment (as % of service exports) in East Asia (all income levels)?
Make the answer very short. 0.53. What is the difference between the highest and the second highest Balance of Payment (as % of service exports) in Cabo Verde?
Keep it short and to the point. 4.36. What is the difference between the highest and the second highest Balance of Payment (as % of service exports) in Italy?
Provide a short and direct response. 0.33. What is the difference between the highest and the lowest Balance of Payment (as % of service exports) of Caribbean small states?
Offer a terse response. 1.68. What is the difference between the highest and the lowest Balance of Payment (as % of service exports) in East Asia (all income levels)?
Make the answer very short. 6.09. What is the difference between the highest and the lowest Balance of Payment (as % of service exports) of Cabo Verde?
Your answer should be very brief. 12.74. What is the difference between the highest and the lowest Balance of Payment (as % of service exports) in Italy?
Provide a short and direct response. 3.06. 